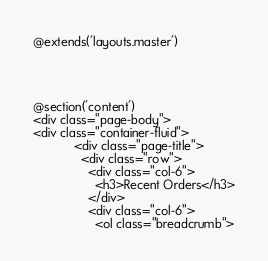<code> <loc_0><loc_0><loc_500><loc_500><_PHP_>
@extends('layouts.master')




@section('content')
<div class="page-body">
<div class="container-fluid">        
            <div class="page-title">
              <div class="row">
                <div class="col-6">
                  <h3>Recent Orders</h3>
                </div>
                <div class="col-6">
                  <ol class="breadcrumb"></code> 